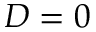Convert formula to latex. <formula><loc_0><loc_0><loc_500><loc_500>D = 0</formula> 